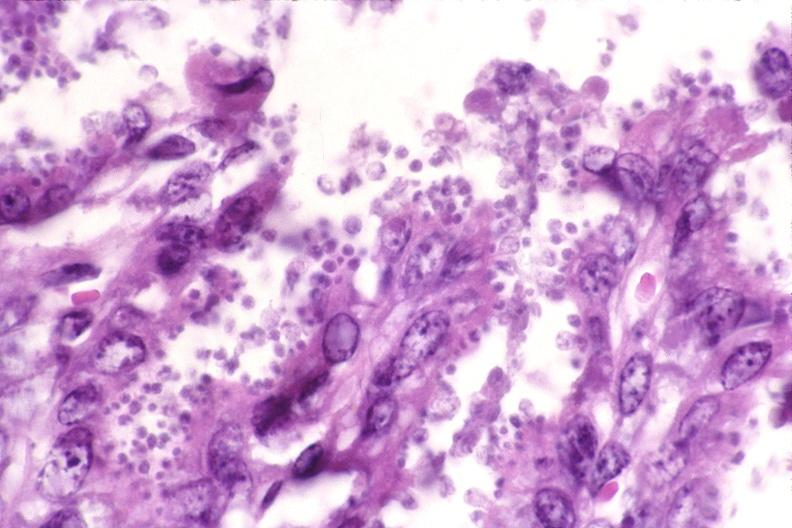where is this from?
Answer the question using a single word or phrase. Gastrointestinal system 